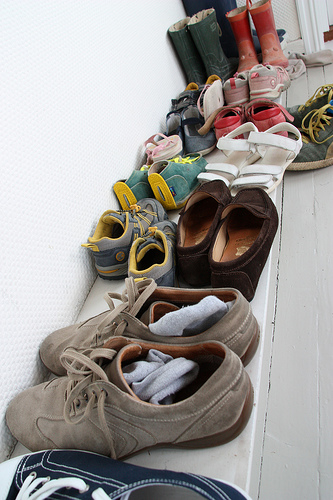<image>
Is there a sock in the shoe? Yes. The sock is contained within or inside the shoe, showing a containment relationship. Where is the shoe in relation to the shoe? Is it to the left of the shoe? Yes. From this viewpoint, the shoe is positioned to the left side relative to the shoe. 